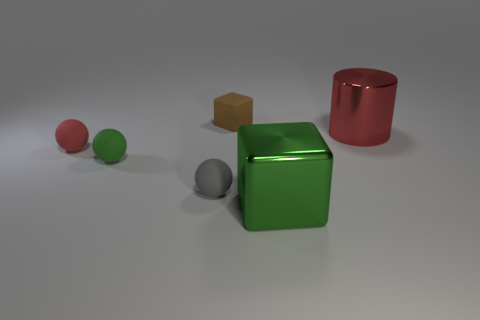Add 3 metal cubes. How many objects exist? 9 Subtract all cylinders. How many objects are left? 5 Subtract all big blue blocks. Subtract all tiny gray matte things. How many objects are left? 5 Add 5 tiny green balls. How many tiny green balls are left? 6 Add 4 green matte objects. How many green matte objects exist? 5 Subtract 0 blue cylinders. How many objects are left? 6 